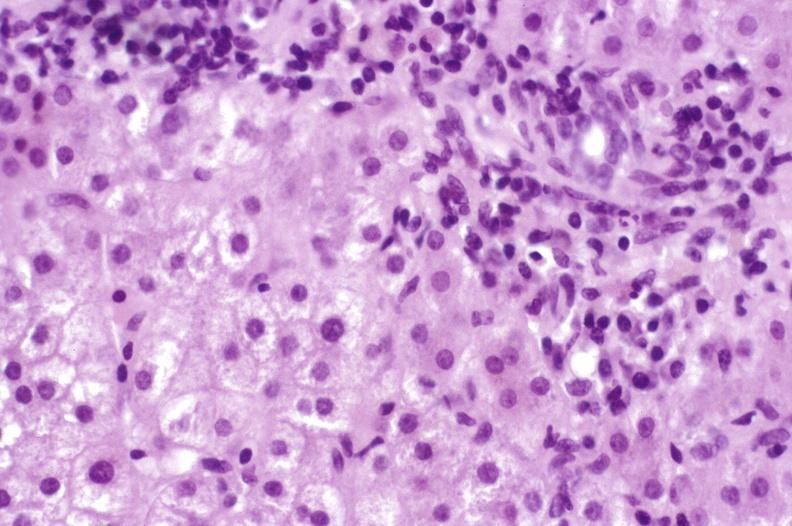what is present?
Answer the question using a single word or phrase. Liver 